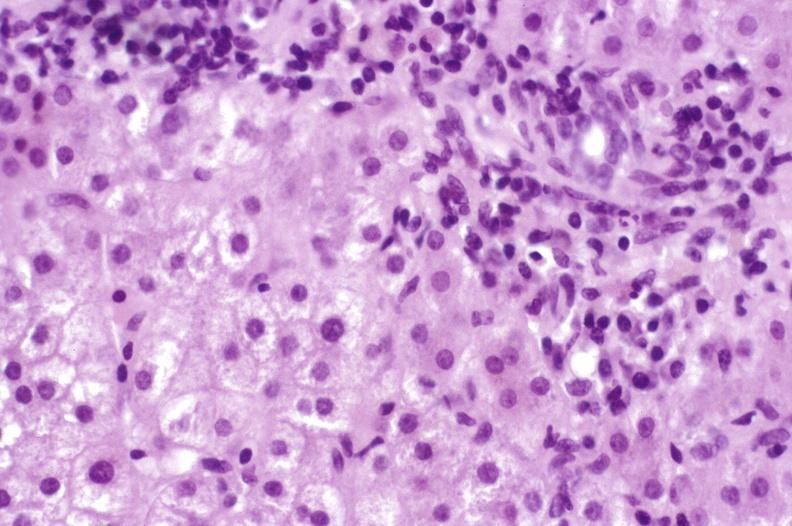what is present?
Answer the question using a single word or phrase. Liver 